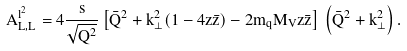Convert formula to latex. <formula><loc_0><loc_0><loc_500><loc_500>A ^ { l ^ { 2 } } _ { L , L } = 4 \frac { s } { \sqrt { Q ^ { 2 } } } \left [ \bar { Q } ^ { 2 } + k _ { \perp } ^ { 2 } ( 1 - 4 z \bar { z } ) - 2 m _ { q } M _ { V } z \bar { z } \right ] \, \left ( \bar { Q } ^ { 2 } + k _ { \perp } ^ { 2 } \right ) .</formula> 